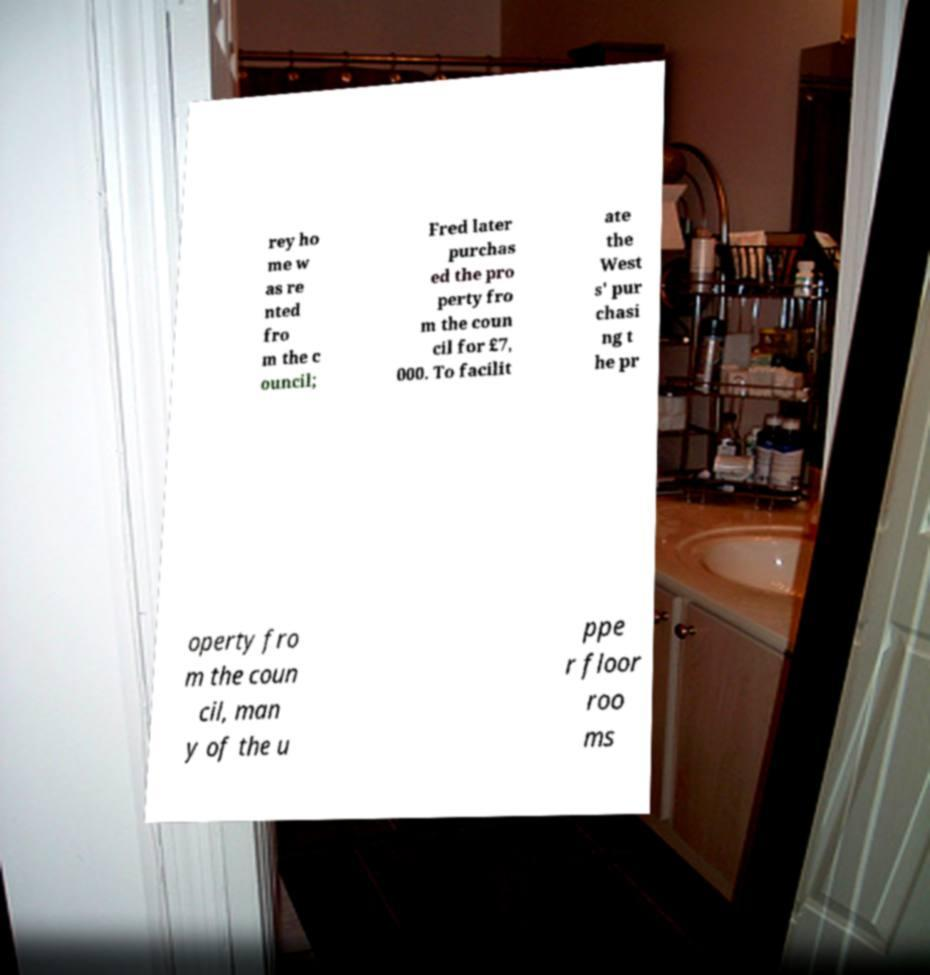Could you assist in decoding the text presented in this image and type it out clearly? rey ho me w as re nted fro m the c ouncil; Fred later purchas ed the pro perty fro m the coun cil for £7, 000. To facilit ate the West s' pur chasi ng t he pr operty fro m the coun cil, man y of the u ppe r floor roo ms 